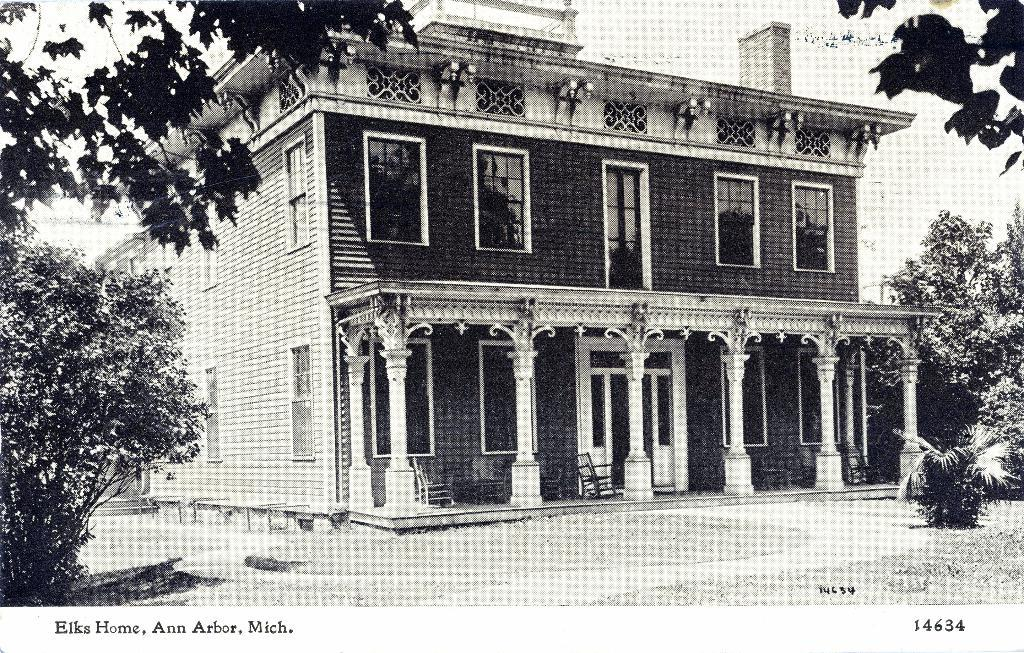What type of structure is present in the image? There is a building in the image. What feature can be seen on the building? The building has windows. What type of furniture is visible in the image? There are chairs in the image. What type of natural elements can be seen in the image? There are trees and a plant in the image. What is the color scheme of the image? The image is black and white in color. Is there any additional marking or text in the image? Yes, there is a watermark in the image. What type of drum can be seen in the image? There is no drum present in the image. Is there a van parked near the building in the image? There is no van mentioned or visible in the image. 